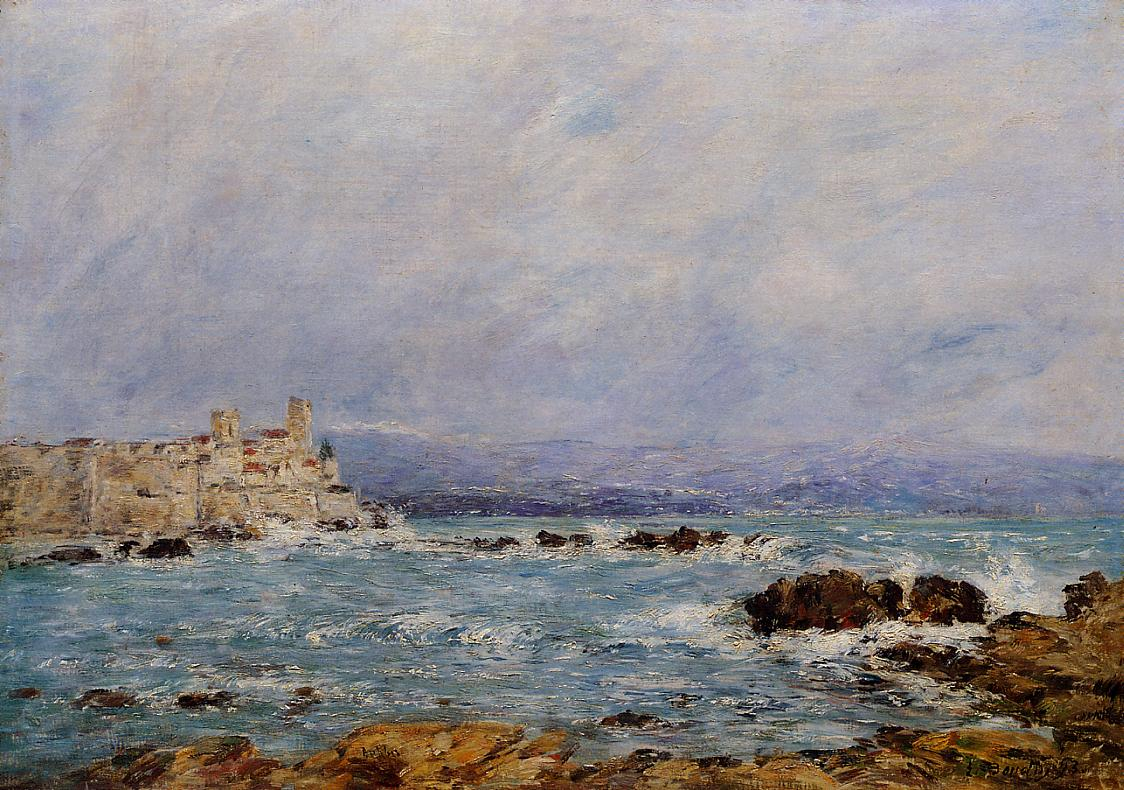What are the key elements in this picture? This remarkable painting, attributed to the impressionist master Claude Monet, showcases a fortress constructed on a rocky coastline. Painted with quick, expressive brushstrokes typical of Monet's style, the composition beautifully captures the rugged texture of the moss-covered rocks against the dynamic blues of the churning sea. The fortress, subtly colored in beige and situated atop the rocks, draws the eye as a focal point amidst the wild natural surroundings. Monet's distinctive signature in the corner confirms his authorship. The emotive quality of the scene, highlighting the interplay between human history and the eternal forces of nature, is rendered with a soft, light-infused palette that suggests a timeless afternoon on the coast. 